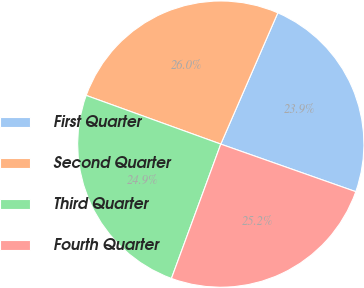Convert chart to OTSL. <chart><loc_0><loc_0><loc_500><loc_500><pie_chart><fcel>First Quarter<fcel>Second Quarter<fcel>Third Quarter<fcel>Fourth Quarter<nl><fcel>23.87%<fcel>26.0%<fcel>24.92%<fcel>25.21%<nl></chart> 